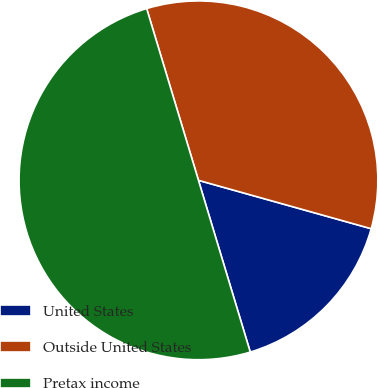Convert chart. <chart><loc_0><loc_0><loc_500><loc_500><pie_chart><fcel>United States<fcel>Outside United States<fcel>Pretax income<nl><fcel>15.99%<fcel>34.01%<fcel>50.0%<nl></chart> 